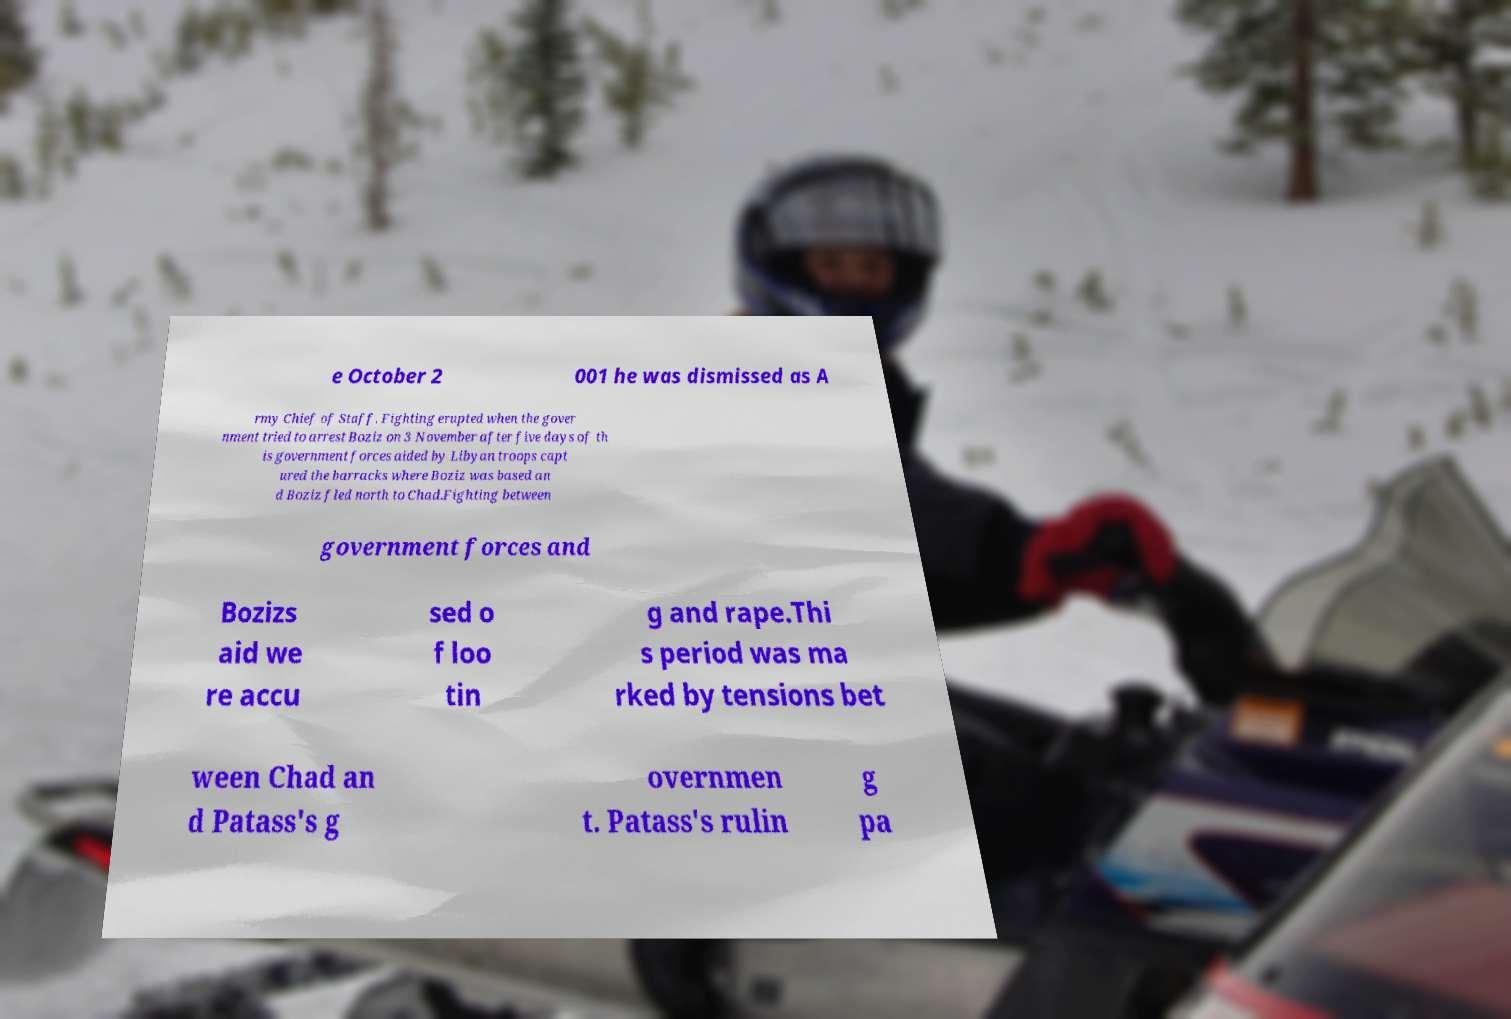Can you read and provide the text displayed in the image?This photo seems to have some interesting text. Can you extract and type it out for me? e October 2 001 he was dismissed as A rmy Chief of Staff. Fighting erupted when the gover nment tried to arrest Boziz on 3 November after five days of th is government forces aided by Libyan troops capt ured the barracks where Boziz was based an d Boziz fled north to Chad.Fighting between government forces and Bozizs aid we re accu sed o f loo tin g and rape.Thi s period was ma rked by tensions bet ween Chad an d Patass's g overnmen t. Patass's rulin g pa 